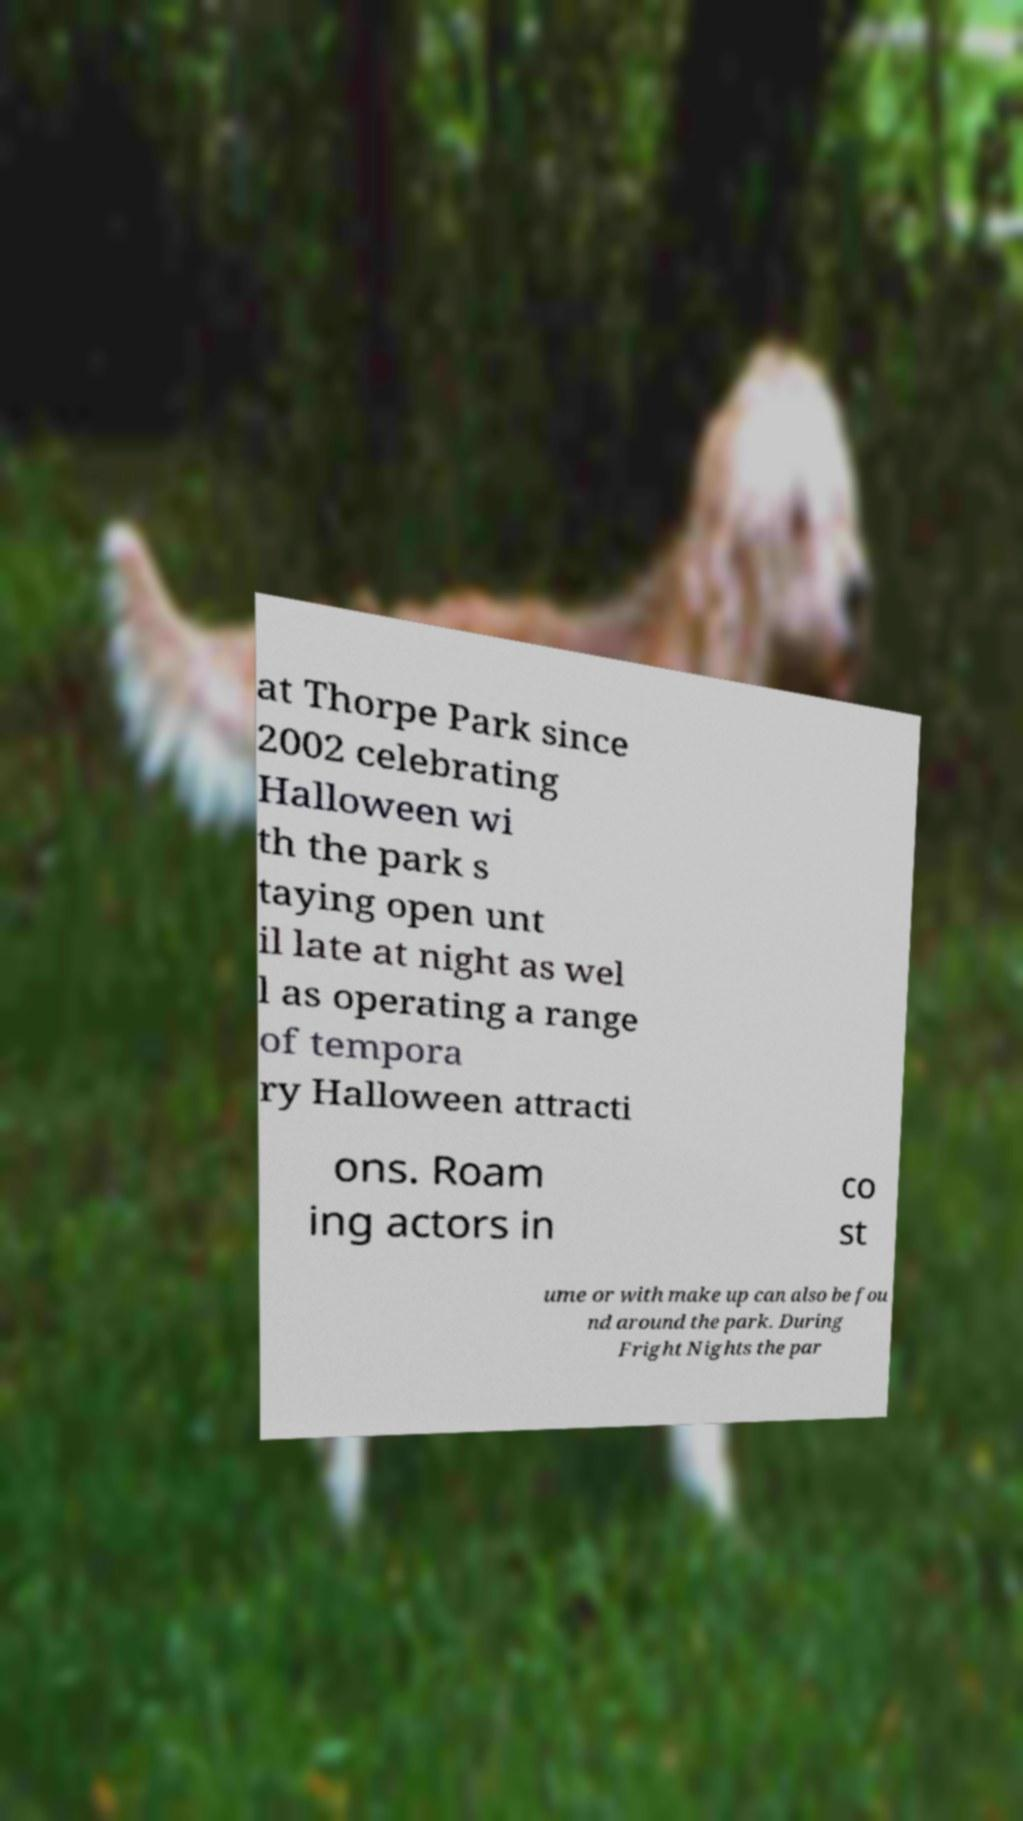Could you assist in decoding the text presented in this image and type it out clearly? at Thorpe Park since 2002 celebrating Halloween wi th the park s taying open unt il late at night as wel l as operating a range of tempora ry Halloween attracti ons. Roam ing actors in co st ume or with make up can also be fou nd around the park. During Fright Nights the par 